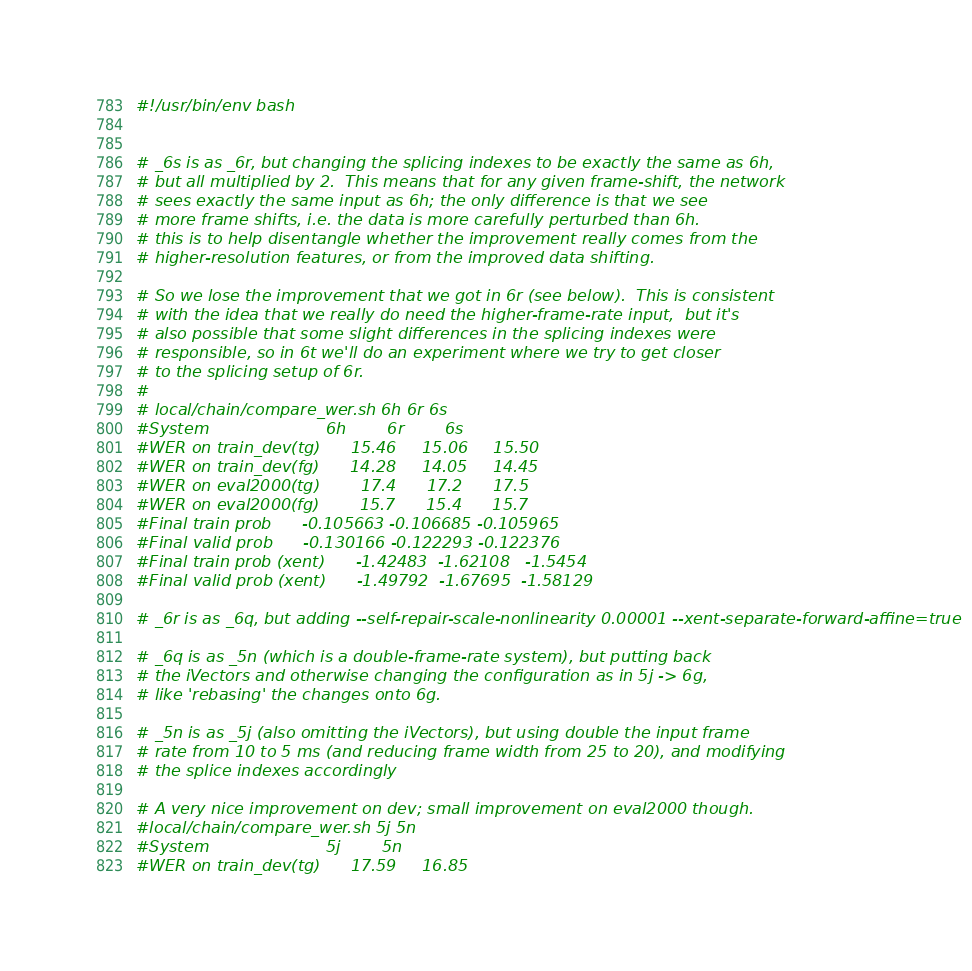Convert code to text. <code><loc_0><loc_0><loc_500><loc_500><_Bash_>#!/usr/bin/env bash


# _6s is as _6r, but changing the splicing indexes to be exactly the same as 6h,
# but all multiplied by 2.  This means that for any given frame-shift, the network
# sees exactly the same input as 6h; the only difference is that we see
# more frame shifts, i.e. the data is more carefully perturbed than 6h.
# this is to help disentangle whether the improvement really comes from the
# higher-resolution features, or from the improved data shifting.

# So we lose the improvement that we got in 6r (see below).  This is consistent
# with the idea that we really do need the higher-frame-rate input,  but it's
# also possible that some slight differences in the splicing indexes were
# responsible, so in 6t we'll do an experiment where we try to get closer
# to the splicing setup of 6r.
#
# local/chain/compare_wer.sh 6h 6r 6s
#System                       6h        6r        6s
#WER on train_dev(tg)      15.46     15.06     15.50
#WER on train_dev(fg)      14.28     14.05     14.45
#WER on eval2000(tg)        17.4      17.2      17.5
#WER on eval2000(fg)        15.7      15.4      15.7
#Final train prob      -0.105663 -0.106685 -0.105965
#Final valid prob      -0.130166 -0.122293 -0.122376
#Final train prob (xent)      -1.42483  -1.62108   -1.5454
#Final valid prob (xent)      -1.49792  -1.67695  -1.58129

# _6r is as _6q, but adding --self-repair-scale-nonlinearity 0.00001 --xent-separate-forward-affine=true

# _6q is as _5n (which is a double-frame-rate system), but putting back
# the iVectors and otherwise changing the configuration as in 5j -> 6g,
# like 'rebasing' the changes onto 6g.

# _5n is as _5j (also omitting the iVectors), but using double the input frame
# rate from 10 to 5 ms (and reducing frame width from 25 to 20), and modifying
# the splice indexes accordingly

# A very nice improvement on dev; small improvement on eval2000 though.
#local/chain/compare_wer.sh 5j 5n
#System                       5j        5n
#WER on train_dev(tg)      17.59     16.85</code> 